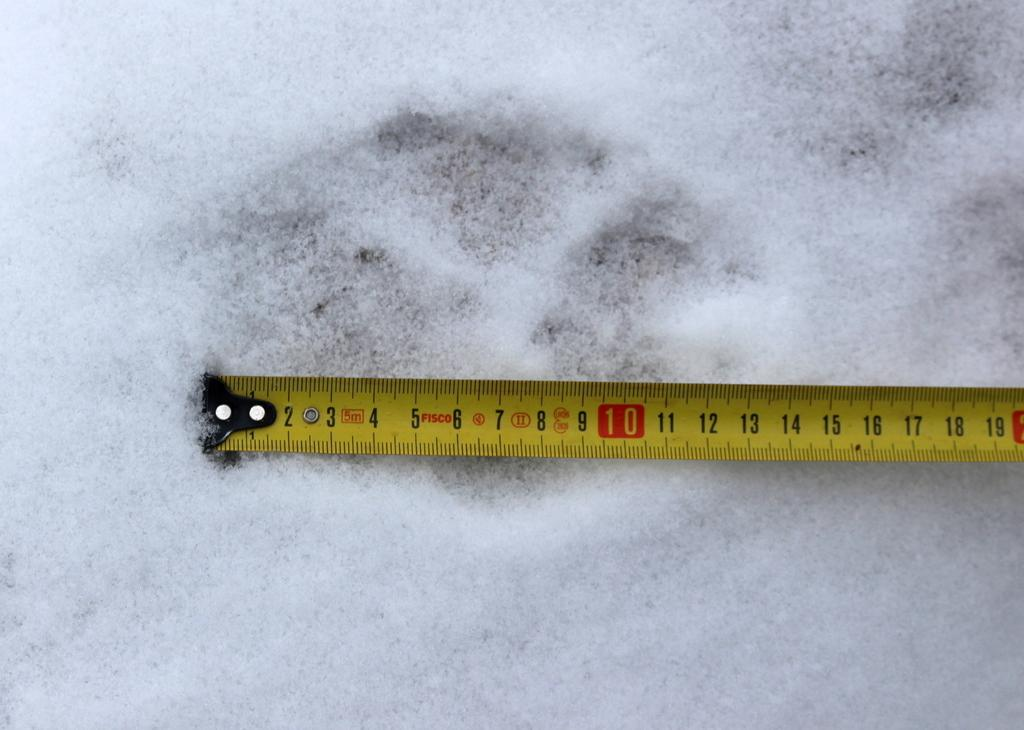<image>
Give a short and clear explanation of the subsequent image. A yellow measuring tape in the snow with the word Fisco on it. 